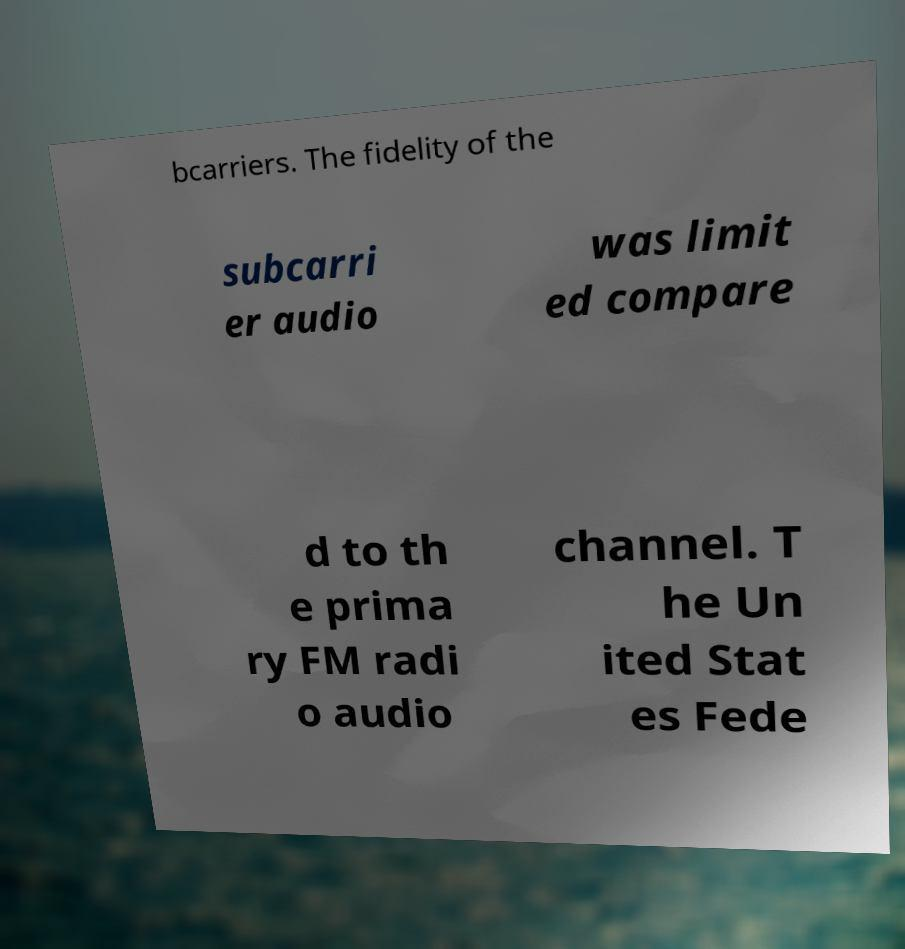I need the written content from this picture converted into text. Can you do that? bcarriers. The fidelity of the subcarri er audio was limit ed compare d to th e prima ry FM radi o audio channel. T he Un ited Stat es Fede 